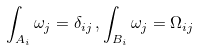<formula> <loc_0><loc_0><loc_500><loc_500>\int _ { A _ { i } } \omega _ { j } = \delta _ { i j } \, , \int _ { B _ { i } } \omega _ { j } = \Omega _ { i j }</formula> 